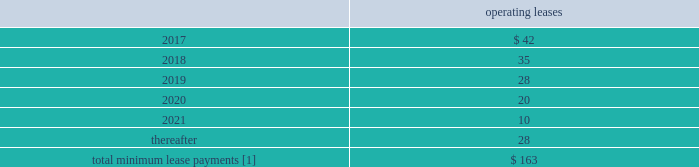F-80 www.thehartford.com the hartford financial services group , inc .
Notes to consolidated financial statements ( continued ) 14 .
Commitments and contingencies ( continued ) future minimum lease commitments as of december 31 , 2016 operating leases .
[1] excludes expected future minimum sublease income of approximately $ 2 , $ 2 , $ 2 , $ 2 , $ 0 and $ 0 in 2017 , 2018 , 2019 , 2020 , 2021 and thereafter respectively .
The company 2019s lease commitments consist primarily of lease agreements for office space , automobiles , and office equipment that expire at various dates .
Unfunded commitments as of december 31 , 2016 , the company has outstanding commitments totaling $ 1.6 billion , of which $ 1.2 billion is committed to fund limited partnership and other alternative investments , which may be called by the partnership during the commitment period to fund the purchase of new investments and partnership expenses .
Additionally , $ 313 of the outstanding commitments relate to various funding obligations associated with private placement securities .
The remaining outstanding commitments of $ 95 relate to mortgage loans the company is expecting to fund in the first half of 2017 .
Guaranty funds and other insurance-related assessments in all states , insurers licensed to transact certain classes of insurance are required to become members of a guaranty fund .
In most states , in the event of the insolvency of an insurer writing any such class of insurance in the state , the guaranty funds may assess its members to pay covered claims of the insolvent insurers .
Assessments are based on each member 2019s proportionate share of written premiums in the state for the classes of insurance in which the insolvent insurer was engaged .
Assessments are generally limited for any year to one or two percent of the premiums written per year depending on the state .
Some states permit member insurers to recover assessments paid through surcharges on policyholders or through full or partial premium tax offsets , while other states permit recovery of assessments through the rate filing process .
Liabilities for guaranty fund and other insurance-related assessments are accrued when an assessment is probable , when it can be reasonably estimated , and when the event obligating the company to pay an imposed or probable assessment has occurred .
Liabilities for guaranty funds and other insurance- related assessments are not discounted and are included as part of other liabilities in the consolidated balance sheets .
As of december 31 , 2016 and 2015 the liability balance was $ 134 and $ 138 , respectively .
As of december 31 , 2016 and 2015 amounts related to premium tax offsets of $ 34 and $ 44 , respectively , were included in other assets .
Derivative commitments certain of the company 2019s derivative agreements contain provisions that are tied to the financial strength ratings , as set by nationally recognized statistical agencies , of the individual legal entity that entered into the derivative agreement .
If the legal entity 2019s financial strength were to fall below certain ratings , the counterparties to the derivative agreements could demand immediate and ongoing full collateralization and in certain instances enable the counterparties to terminate the agreements and demand immediate settlement of all outstanding derivative positions traded under each impacted bilateral agreement .
The settlement amount is determined by netting the derivative positions transacted under each agreement .
If the termination rights were to be exercised by the counterparties , it could impact the legal entity 2019s ability to conduct hedging activities by increasing the associated costs and decreasing the willingness of counterparties to transact with the legal entity .
The aggregate fair value of all derivative instruments with credit-risk-related contingent features that are in a net liability position as of december 31 , 2016 was $ 1.4 billion .
Of this $ 1.4 billion , the legal entities have posted collateral of $ 1.7 billion in the normal course of business .
In addition , the company has posted collateral of $ 31 associated with a customized gmwb derivative .
Based on derivative market values as of december 31 , 2016 , a downgrade of one level below the current financial strength ratings by either moody 2019s or s&p would not require additional assets to be posted as collateral .
Based on derivative market values as of december 31 , 2016 , a downgrade of two levels below the current financial strength ratings by either moody 2019s or s&p would require additional $ 10 of assets to be posted as collateral .
These collateral amounts could change as derivative market values change , as a result of changes in our hedging activities or to the extent changes in contractual terms are negotiated .
The nature of the collateral that we post , when required , is primarily in the form of u.s .
Treasury bills , u.s .
Treasury notes and government agency securities .
Guarantees in the ordinary course of selling businesses or entities to third parties , the company has agreed to indemnify purchasers for losses arising subsequent to the closing due to breaches of representations and warranties with respect to the business or entity being sold or with respect to covenants and obligations of the company and/or its subsidiaries .
These obligations are typically subject to various time limitations , defined by the contract or by operation of law , such as statutes of limitation .
In some cases , the maximum potential obligation is subject to contractual limitations , while in other cases such limitations are not specified or applicable .
The company does not expect to make any payments on these guarantees and is not carrying any liabilities associated with these guarantees. .
As of december 31 , 2016 what was the percent of the total future minimum lease commitments for operating leases that was due in 2017? 
Computations: (42 / 163)
Answer: 0.25767. 